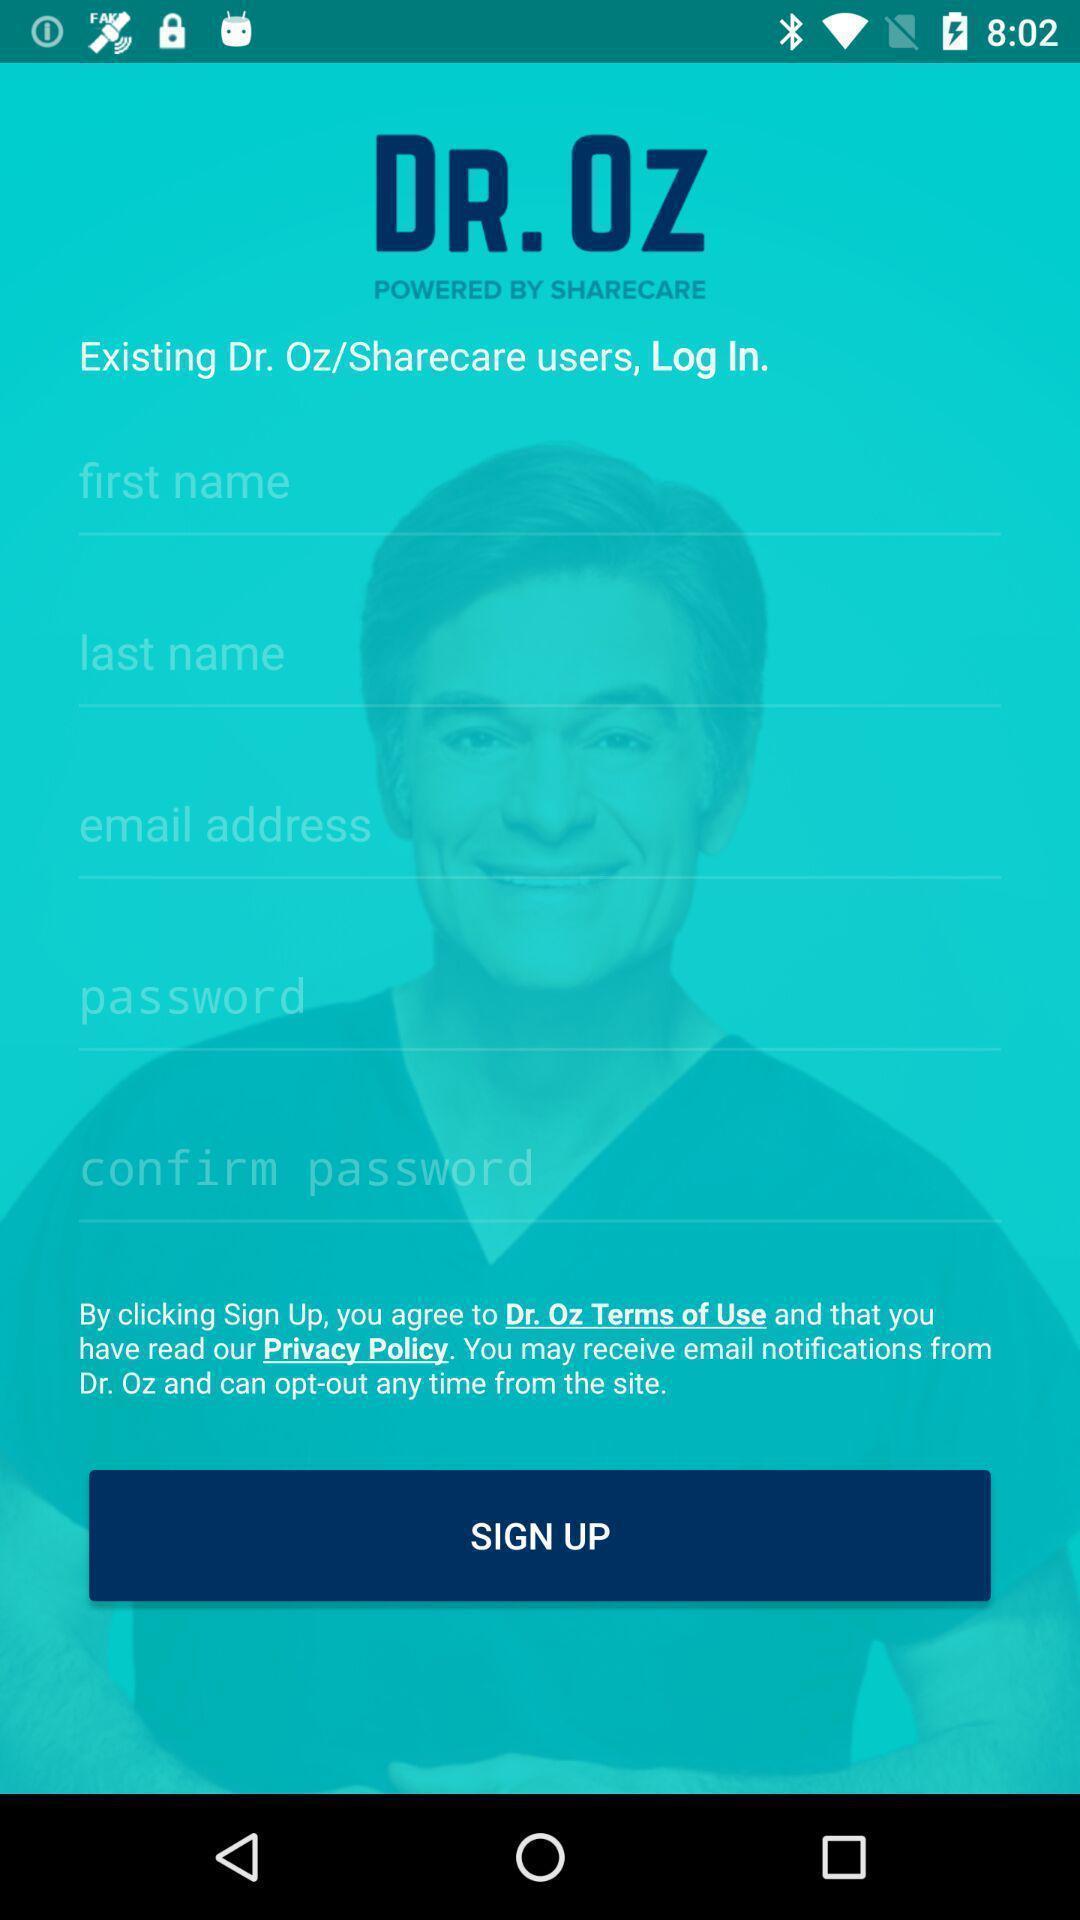Describe the key features of this screenshot. Sign up page of a healthcare application. 